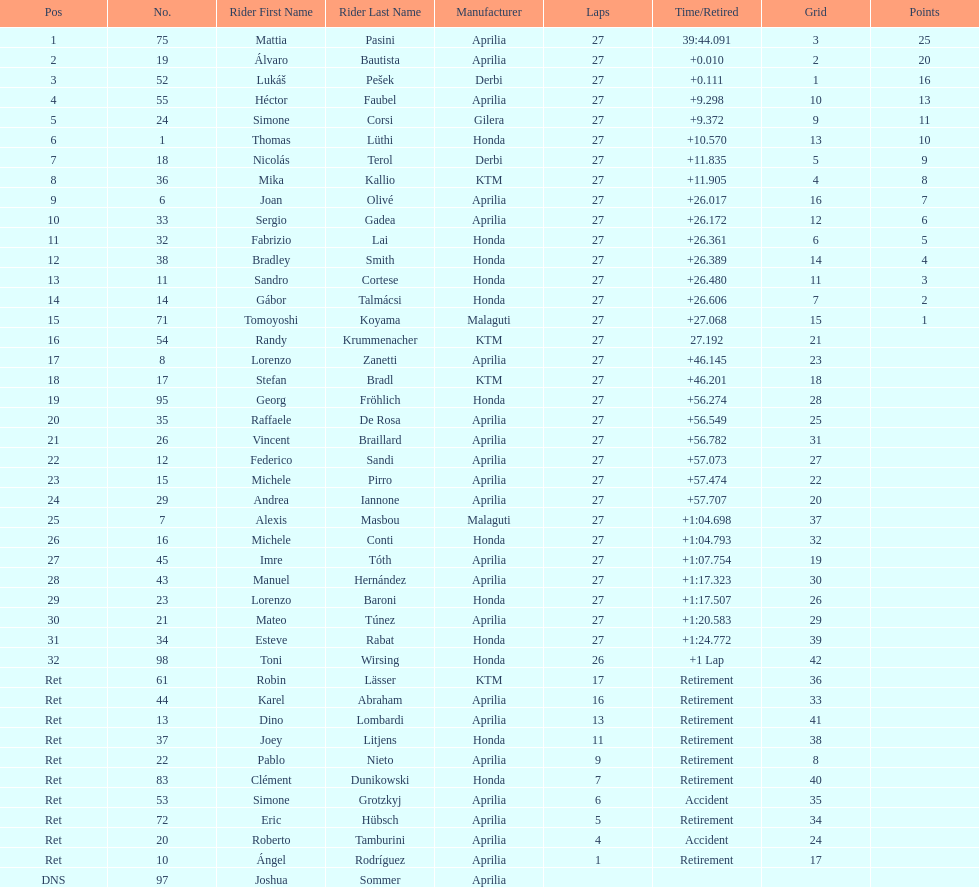What was the total number of positions in the 125cc classification? 43. 